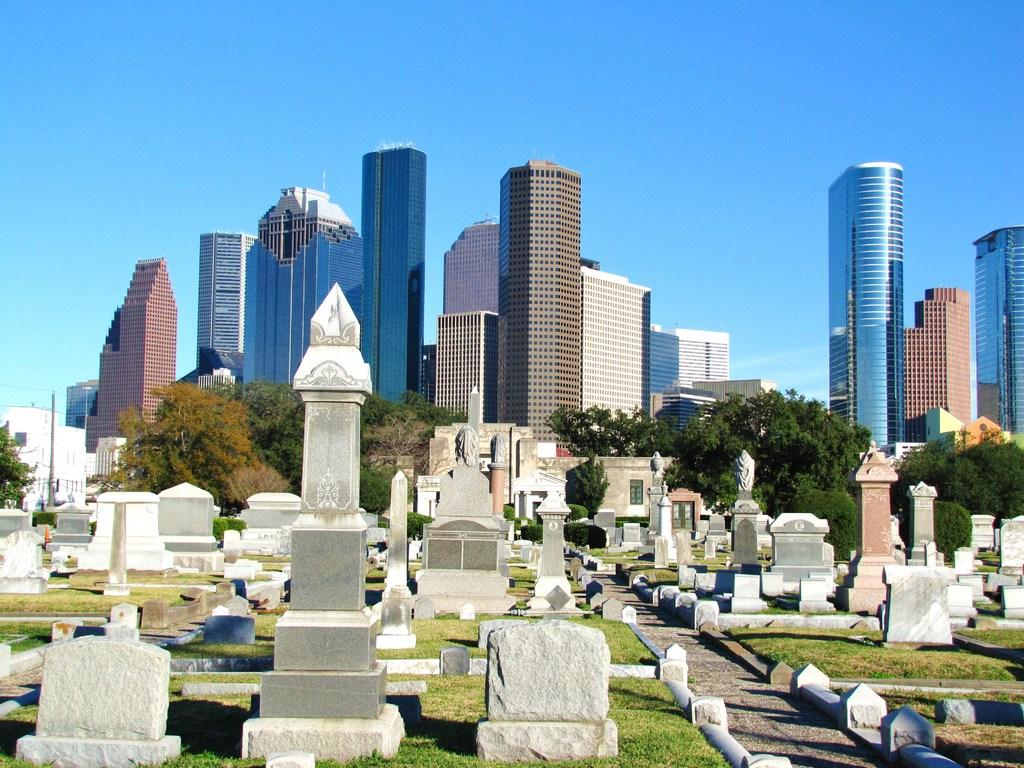What type of location is depicted in the image? There is a graveyard in the image. What is the surface of the graves made of? The graves are on a grass surface. What can be seen in the background of the image? There are trees and tower buildings visible in the background. What is visible at the top of the image? The sky is visible in the image. Can you see any cobwebs on the gravestones in the image? There is no mention of cobwebs in the provided facts, so we cannot determine if they are present in the image. 